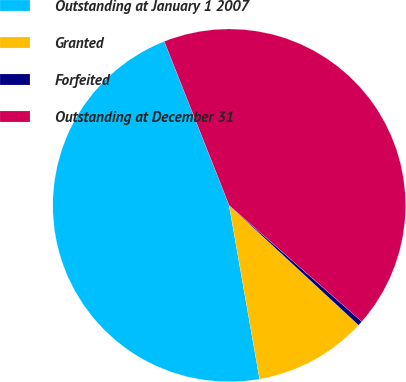Convert chart to OTSL. <chart><loc_0><loc_0><loc_500><loc_500><pie_chart><fcel>Outstanding at January 1 2007<fcel>Granted<fcel>Forfeited<fcel>Outstanding at December 31<nl><fcel>46.76%<fcel>10.35%<fcel>0.44%<fcel>42.44%<nl></chart> 